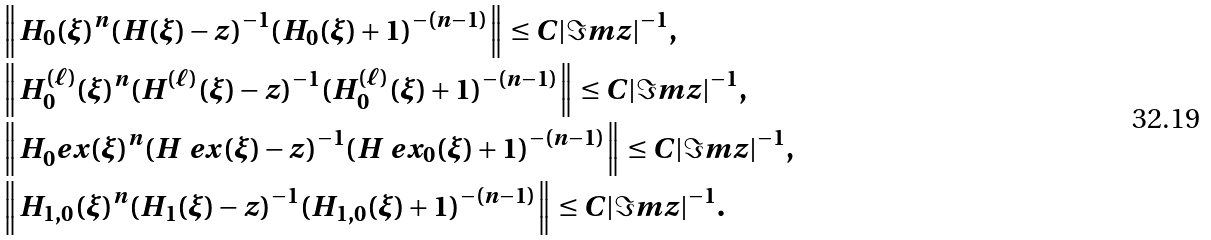Convert formula to latex. <formula><loc_0><loc_0><loc_500><loc_500>& \left \| H _ { 0 } ( \xi ) ^ { n } ( H ( \xi ) - z ) ^ { - 1 } ( H _ { 0 } ( \xi ) + 1 ) ^ { - ( n - 1 ) } \right \| \leq C | \Im m z | ^ { - 1 } , \\ & \left \| H _ { 0 } ^ { ( \ell ) } ( \xi ) ^ { n } ( H ^ { ( \ell ) } ( \xi ) - z ) ^ { - 1 } ( H _ { 0 } ^ { ( \ell ) } ( \xi ) + 1 ) ^ { - ( n - 1 ) } \right \| \leq C | \Im m z | ^ { - 1 } , \\ & \left \| H _ { 0 } ^ { \ } e x ( \xi ) ^ { n } ( H ^ { \ } e x ( \xi ) - z ) ^ { - 1 } ( H ^ { \ } e x _ { 0 } ( \xi ) + 1 ) ^ { - ( n - 1 ) } \right \| \leq C | \Im m z | ^ { - 1 } , \\ & \left \| H _ { 1 , 0 } ( \xi ) ^ { n } ( H _ { 1 } ( \xi ) - z ) ^ { - 1 } ( H _ { 1 , 0 } ( \xi ) + 1 ) ^ { - ( n - 1 ) } \right \| \leq C | \Im m z | ^ { - 1 } .</formula> 